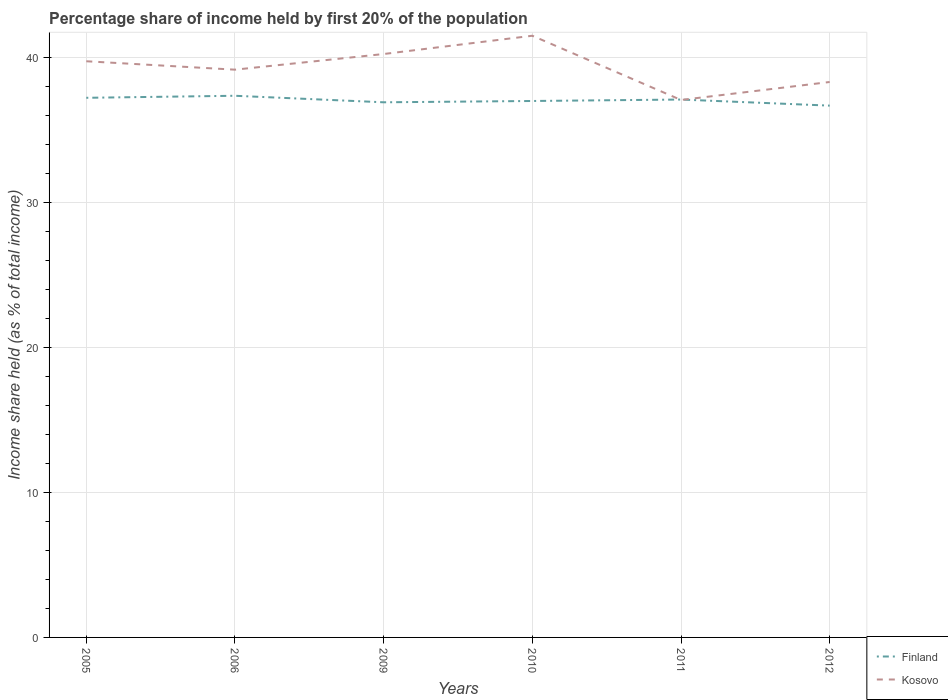How many different coloured lines are there?
Keep it short and to the point. 2. Does the line corresponding to Kosovo intersect with the line corresponding to Finland?
Provide a short and direct response. Yes. Across all years, what is the maximum share of income held by first 20% of the population in Kosovo?
Offer a terse response. 37.07. What is the total share of income held by first 20% of the population in Finland in the graph?
Your response must be concise. -0.1. What is the difference between the highest and the second highest share of income held by first 20% of the population in Finland?
Give a very brief answer. 0.68. How many lines are there?
Your answer should be very brief. 2. How many years are there in the graph?
Provide a short and direct response. 6. Does the graph contain any zero values?
Provide a succinct answer. No. Where does the legend appear in the graph?
Provide a short and direct response. Bottom right. What is the title of the graph?
Offer a terse response. Percentage share of income held by first 20% of the population. Does "Macedonia" appear as one of the legend labels in the graph?
Offer a terse response. No. What is the label or title of the X-axis?
Your response must be concise. Years. What is the label or title of the Y-axis?
Your response must be concise. Income share held (as % of total income). What is the Income share held (as % of total income) in Finland in 2005?
Provide a short and direct response. 37.22. What is the Income share held (as % of total income) of Kosovo in 2005?
Your answer should be very brief. 39.74. What is the Income share held (as % of total income) in Finland in 2006?
Your answer should be very brief. 37.36. What is the Income share held (as % of total income) in Kosovo in 2006?
Give a very brief answer. 39.16. What is the Income share held (as % of total income) of Finland in 2009?
Your answer should be very brief. 36.91. What is the Income share held (as % of total income) of Kosovo in 2009?
Provide a succinct answer. 40.24. What is the Income share held (as % of total income) in Finland in 2010?
Your answer should be compact. 37. What is the Income share held (as % of total income) in Kosovo in 2010?
Your response must be concise. 41.5. What is the Income share held (as % of total income) in Finland in 2011?
Offer a terse response. 37.1. What is the Income share held (as % of total income) in Kosovo in 2011?
Your answer should be compact. 37.07. What is the Income share held (as % of total income) of Finland in 2012?
Give a very brief answer. 36.68. What is the Income share held (as % of total income) in Kosovo in 2012?
Make the answer very short. 38.31. Across all years, what is the maximum Income share held (as % of total income) of Finland?
Your response must be concise. 37.36. Across all years, what is the maximum Income share held (as % of total income) in Kosovo?
Offer a terse response. 41.5. Across all years, what is the minimum Income share held (as % of total income) in Finland?
Provide a short and direct response. 36.68. Across all years, what is the minimum Income share held (as % of total income) of Kosovo?
Offer a very short reply. 37.07. What is the total Income share held (as % of total income) in Finland in the graph?
Your answer should be very brief. 222.27. What is the total Income share held (as % of total income) in Kosovo in the graph?
Provide a succinct answer. 236.02. What is the difference between the Income share held (as % of total income) in Finland in 2005 and that in 2006?
Give a very brief answer. -0.14. What is the difference between the Income share held (as % of total income) in Kosovo in 2005 and that in 2006?
Your answer should be compact. 0.58. What is the difference between the Income share held (as % of total income) of Finland in 2005 and that in 2009?
Your answer should be very brief. 0.31. What is the difference between the Income share held (as % of total income) of Finland in 2005 and that in 2010?
Keep it short and to the point. 0.22. What is the difference between the Income share held (as % of total income) of Kosovo in 2005 and that in 2010?
Your answer should be compact. -1.76. What is the difference between the Income share held (as % of total income) of Finland in 2005 and that in 2011?
Provide a short and direct response. 0.12. What is the difference between the Income share held (as % of total income) of Kosovo in 2005 and that in 2011?
Your response must be concise. 2.67. What is the difference between the Income share held (as % of total income) in Finland in 2005 and that in 2012?
Your answer should be very brief. 0.54. What is the difference between the Income share held (as % of total income) of Kosovo in 2005 and that in 2012?
Provide a short and direct response. 1.43. What is the difference between the Income share held (as % of total income) in Finland in 2006 and that in 2009?
Ensure brevity in your answer.  0.45. What is the difference between the Income share held (as % of total income) of Kosovo in 2006 and that in 2009?
Make the answer very short. -1.08. What is the difference between the Income share held (as % of total income) in Finland in 2006 and that in 2010?
Ensure brevity in your answer.  0.36. What is the difference between the Income share held (as % of total income) of Kosovo in 2006 and that in 2010?
Provide a succinct answer. -2.34. What is the difference between the Income share held (as % of total income) in Finland in 2006 and that in 2011?
Offer a terse response. 0.26. What is the difference between the Income share held (as % of total income) in Kosovo in 2006 and that in 2011?
Offer a terse response. 2.09. What is the difference between the Income share held (as % of total income) of Finland in 2006 and that in 2012?
Your answer should be very brief. 0.68. What is the difference between the Income share held (as % of total income) in Finland in 2009 and that in 2010?
Your answer should be compact. -0.09. What is the difference between the Income share held (as % of total income) of Kosovo in 2009 and that in 2010?
Provide a succinct answer. -1.26. What is the difference between the Income share held (as % of total income) of Finland in 2009 and that in 2011?
Your response must be concise. -0.19. What is the difference between the Income share held (as % of total income) of Kosovo in 2009 and that in 2011?
Provide a short and direct response. 3.17. What is the difference between the Income share held (as % of total income) in Finland in 2009 and that in 2012?
Ensure brevity in your answer.  0.23. What is the difference between the Income share held (as % of total income) in Kosovo in 2009 and that in 2012?
Your response must be concise. 1.93. What is the difference between the Income share held (as % of total income) of Finland in 2010 and that in 2011?
Your response must be concise. -0.1. What is the difference between the Income share held (as % of total income) of Kosovo in 2010 and that in 2011?
Your answer should be very brief. 4.43. What is the difference between the Income share held (as % of total income) of Finland in 2010 and that in 2012?
Make the answer very short. 0.32. What is the difference between the Income share held (as % of total income) of Kosovo in 2010 and that in 2012?
Provide a succinct answer. 3.19. What is the difference between the Income share held (as % of total income) of Finland in 2011 and that in 2012?
Offer a terse response. 0.42. What is the difference between the Income share held (as % of total income) of Kosovo in 2011 and that in 2012?
Provide a short and direct response. -1.24. What is the difference between the Income share held (as % of total income) in Finland in 2005 and the Income share held (as % of total income) in Kosovo in 2006?
Keep it short and to the point. -1.94. What is the difference between the Income share held (as % of total income) in Finland in 2005 and the Income share held (as % of total income) in Kosovo in 2009?
Ensure brevity in your answer.  -3.02. What is the difference between the Income share held (as % of total income) in Finland in 2005 and the Income share held (as % of total income) in Kosovo in 2010?
Provide a succinct answer. -4.28. What is the difference between the Income share held (as % of total income) of Finland in 2005 and the Income share held (as % of total income) of Kosovo in 2012?
Give a very brief answer. -1.09. What is the difference between the Income share held (as % of total income) in Finland in 2006 and the Income share held (as % of total income) in Kosovo in 2009?
Keep it short and to the point. -2.88. What is the difference between the Income share held (as % of total income) in Finland in 2006 and the Income share held (as % of total income) in Kosovo in 2010?
Offer a very short reply. -4.14. What is the difference between the Income share held (as % of total income) of Finland in 2006 and the Income share held (as % of total income) of Kosovo in 2011?
Provide a short and direct response. 0.29. What is the difference between the Income share held (as % of total income) of Finland in 2006 and the Income share held (as % of total income) of Kosovo in 2012?
Your response must be concise. -0.95. What is the difference between the Income share held (as % of total income) of Finland in 2009 and the Income share held (as % of total income) of Kosovo in 2010?
Make the answer very short. -4.59. What is the difference between the Income share held (as % of total income) of Finland in 2009 and the Income share held (as % of total income) of Kosovo in 2011?
Provide a succinct answer. -0.16. What is the difference between the Income share held (as % of total income) in Finland in 2009 and the Income share held (as % of total income) in Kosovo in 2012?
Provide a short and direct response. -1.4. What is the difference between the Income share held (as % of total income) of Finland in 2010 and the Income share held (as % of total income) of Kosovo in 2011?
Provide a succinct answer. -0.07. What is the difference between the Income share held (as % of total income) in Finland in 2010 and the Income share held (as % of total income) in Kosovo in 2012?
Offer a very short reply. -1.31. What is the difference between the Income share held (as % of total income) of Finland in 2011 and the Income share held (as % of total income) of Kosovo in 2012?
Ensure brevity in your answer.  -1.21. What is the average Income share held (as % of total income) of Finland per year?
Your answer should be very brief. 37.05. What is the average Income share held (as % of total income) in Kosovo per year?
Make the answer very short. 39.34. In the year 2005, what is the difference between the Income share held (as % of total income) of Finland and Income share held (as % of total income) of Kosovo?
Your answer should be very brief. -2.52. In the year 2006, what is the difference between the Income share held (as % of total income) of Finland and Income share held (as % of total income) of Kosovo?
Give a very brief answer. -1.8. In the year 2009, what is the difference between the Income share held (as % of total income) of Finland and Income share held (as % of total income) of Kosovo?
Keep it short and to the point. -3.33. In the year 2010, what is the difference between the Income share held (as % of total income) in Finland and Income share held (as % of total income) in Kosovo?
Provide a succinct answer. -4.5. In the year 2012, what is the difference between the Income share held (as % of total income) of Finland and Income share held (as % of total income) of Kosovo?
Provide a succinct answer. -1.63. What is the ratio of the Income share held (as % of total income) in Kosovo in 2005 to that in 2006?
Your response must be concise. 1.01. What is the ratio of the Income share held (as % of total income) in Finland in 2005 to that in 2009?
Ensure brevity in your answer.  1.01. What is the ratio of the Income share held (as % of total income) in Kosovo in 2005 to that in 2009?
Give a very brief answer. 0.99. What is the ratio of the Income share held (as % of total income) in Finland in 2005 to that in 2010?
Make the answer very short. 1.01. What is the ratio of the Income share held (as % of total income) of Kosovo in 2005 to that in 2010?
Make the answer very short. 0.96. What is the ratio of the Income share held (as % of total income) in Kosovo in 2005 to that in 2011?
Keep it short and to the point. 1.07. What is the ratio of the Income share held (as % of total income) in Finland in 2005 to that in 2012?
Offer a terse response. 1.01. What is the ratio of the Income share held (as % of total income) of Kosovo in 2005 to that in 2012?
Offer a very short reply. 1.04. What is the ratio of the Income share held (as % of total income) of Finland in 2006 to that in 2009?
Your response must be concise. 1.01. What is the ratio of the Income share held (as % of total income) of Kosovo in 2006 to that in 2009?
Make the answer very short. 0.97. What is the ratio of the Income share held (as % of total income) of Finland in 2006 to that in 2010?
Offer a very short reply. 1.01. What is the ratio of the Income share held (as % of total income) in Kosovo in 2006 to that in 2010?
Give a very brief answer. 0.94. What is the ratio of the Income share held (as % of total income) in Finland in 2006 to that in 2011?
Keep it short and to the point. 1.01. What is the ratio of the Income share held (as % of total income) of Kosovo in 2006 to that in 2011?
Ensure brevity in your answer.  1.06. What is the ratio of the Income share held (as % of total income) of Finland in 2006 to that in 2012?
Offer a terse response. 1.02. What is the ratio of the Income share held (as % of total income) of Kosovo in 2006 to that in 2012?
Your response must be concise. 1.02. What is the ratio of the Income share held (as % of total income) of Kosovo in 2009 to that in 2010?
Provide a succinct answer. 0.97. What is the ratio of the Income share held (as % of total income) in Finland in 2009 to that in 2011?
Make the answer very short. 0.99. What is the ratio of the Income share held (as % of total income) of Kosovo in 2009 to that in 2011?
Offer a very short reply. 1.09. What is the ratio of the Income share held (as % of total income) in Kosovo in 2009 to that in 2012?
Make the answer very short. 1.05. What is the ratio of the Income share held (as % of total income) in Kosovo in 2010 to that in 2011?
Ensure brevity in your answer.  1.12. What is the ratio of the Income share held (as % of total income) of Finland in 2010 to that in 2012?
Your response must be concise. 1.01. What is the ratio of the Income share held (as % of total income) of Finland in 2011 to that in 2012?
Provide a short and direct response. 1.01. What is the ratio of the Income share held (as % of total income) of Kosovo in 2011 to that in 2012?
Ensure brevity in your answer.  0.97. What is the difference between the highest and the second highest Income share held (as % of total income) in Finland?
Ensure brevity in your answer.  0.14. What is the difference between the highest and the second highest Income share held (as % of total income) of Kosovo?
Offer a very short reply. 1.26. What is the difference between the highest and the lowest Income share held (as % of total income) in Finland?
Your response must be concise. 0.68. What is the difference between the highest and the lowest Income share held (as % of total income) in Kosovo?
Keep it short and to the point. 4.43. 